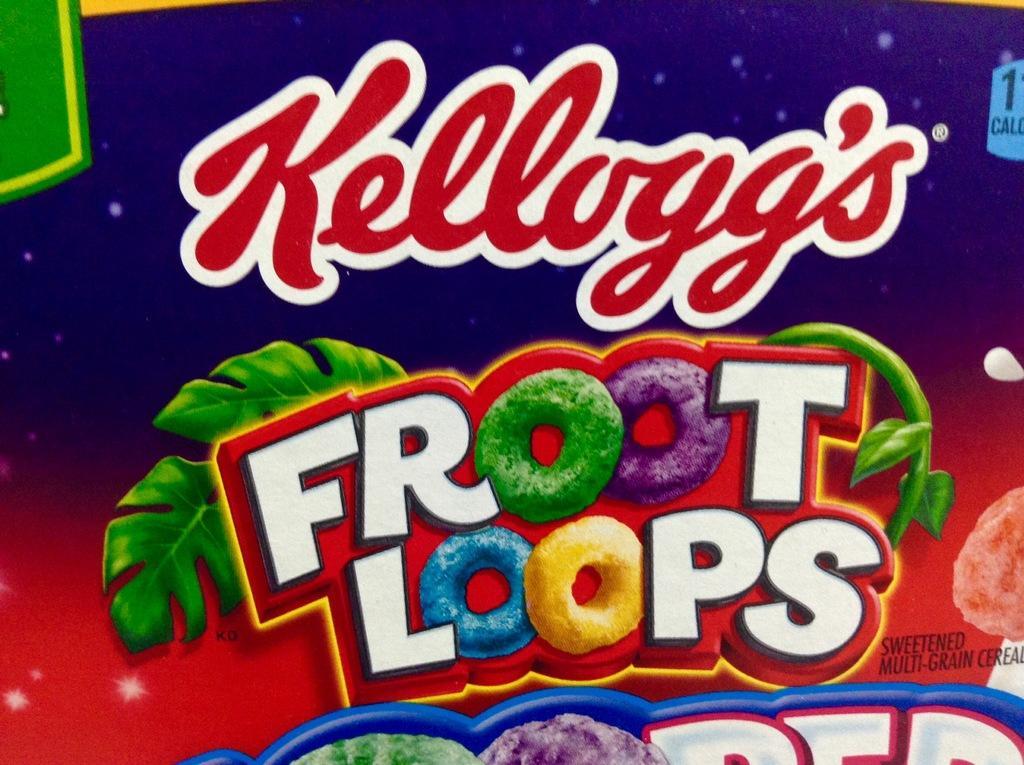Describe this image in one or two sentences. In this image I can see the box. On the box I can see the name Kellogg's fruit loops is written and the box is colorful. 